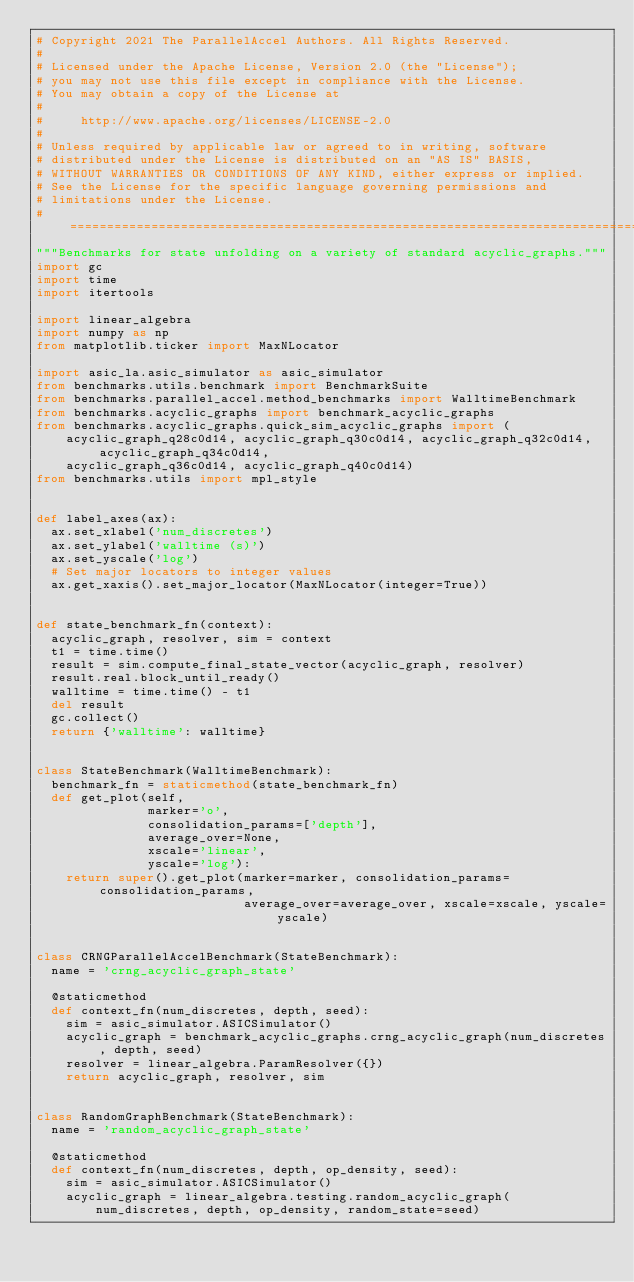<code> <loc_0><loc_0><loc_500><loc_500><_Python_># Copyright 2021 The ParallelAccel Authors. All Rights Reserved.
#
# Licensed under the Apache License, Version 2.0 (the "License");
# you may not use this file except in compliance with the License.
# You may obtain a copy of the License at
#
#     http://www.apache.org/licenses/LICENSE-2.0
#
# Unless required by applicable law or agreed to in writing, software
# distributed under the License is distributed on an "AS IS" BASIS,
# WITHOUT WARRANTIES OR CONDITIONS OF ANY KIND, either express or implied.
# See the License for the specific language governing permissions and
# limitations under the License.
# =============================================================================
"""Benchmarks for state unfolding on a variety of standard acyclic_graphs."""
import gc
import time
import itertools

import linear_algebra
import numpy as np
from matplotlib.ticker import MaxNLocator

import asic_la.asic_simulator as asic_simulator
from benchmarks.utils.benchmark import BenchmarkSuite
from benchmarks.parallel_accel.method_benchmarks import WalltimeBenchmark
from benchmarks.acyclic_graphs import benchmark_acyclic_graphs
from benchmarks.acyclic_graphs.quick_sim_acyclic_graphs import (
    acyclic_graph_q28c0d14, acyclic_graph_q30c0d14, acyclic_graph_q32c0d14, acyclic_graph_q34c0d14,
    acyclic_graph_q36c0d14, acyclic_graph_q40c0d14)
from benchmarks.utils import mpl_style


def label_axes(ax):
  ax.set_xlabel('num_discretes')
  ax.set_ylabel('walltime (s)')
  ax.set_yscale('log')
  # Set major locators to integer values
  ax.get_xaxis().set_major_locator(MaxNLocator(integer=True))


def state_benchmark_fn(context):
  acyclic_graph, resolver, sim = context
  t1 = time.time()
  result = sim.compute_final_state_vector(acyclic_graph, resolver)
  result.real.block_until_ready()
  walltime = time.time() - t1
  del result
  gc.collect()
  return {'walltime': walltime}


class StateBenchmark(WalltimeBenchmark):
  benchmark_fn = staticmethod(state_benchmark_fn)
  def get_plot(self,
               marker='o',
               consolidation_params=['depth'],
               average_over=None,
               xscale='linear',
               yscale='log'):
    return super().get_plot(marker=marker, consolidation_params=consolidation_params,
                            average_over=average_over, xscale=xscale, yscale=yscale)


class CRNGParallelAccelBenchmark(StateBenchmark):
  name = 'crng_acyclic_graph_state'

  @staticmethod
  def context_fn(num_discretes, depth, seed):
    sim = asic_simulator.ASICSimulator()
    acyclic_graph = benchmark_acyclic_graphs.crng_acyclic_graph(num_discretes, depth, seed)
    resolver = linear_algebra.ParamResolver({})
    return acyclic_graph, resolver, sim


class RandomGraphBenchmark(StateBenchmark):
  name = 'random_acyclic_graph_state'

  @staticmethod
  def context_fn(num_discretes, depth, op_density, seed):
    sim = asic_simulator.ASICSimulator()
    acyclic_graph = linear_algebra.testing.random_acyclic_graph(
        num_discretes, depth, op_density, random_state=seed)</code> 